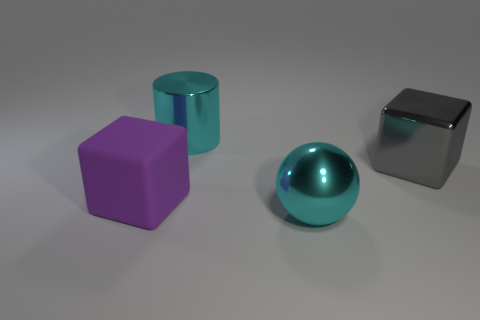Is there anything else that has the same shape as the purple thing?
Offer a very short reply. Yes. What is the big thing that is left of the cyan shiny sphere and in front of the gray metal thing made of?
Make the answer very short. Rubber. Does the large sphere have the same material as the cube on the left side of the large ball?
Make the answer very short. No. What number of things are big brown spheres or big shiny things that are to the left of the big gray metallic block?
Offer a terse response. 2. Does the cyan object behind the big cyan ball have the same size as the sphere in front of the large gray shiny object?
Offer a very short reply. Yes. What number of other things are there of the same color as the large metal block?
Your answer should be compact. 0. There is a cyan shiny object in front of the large cyan object behind the large gray object; how big is it?
Keep it short and to the point. Large. What color is the large rubber object that is the same shape as the gray metal object?
Your answer should be compact. Purple. Are there the same number of rubber blocks left of the big purple rubber thing and small purple rubber cylinders?
Offer a terse response. Yes. Is there a cube that is to the right of the large cyan metallic thing in front of the large cyan cylinder?
Offer a very short reply. Yes. 